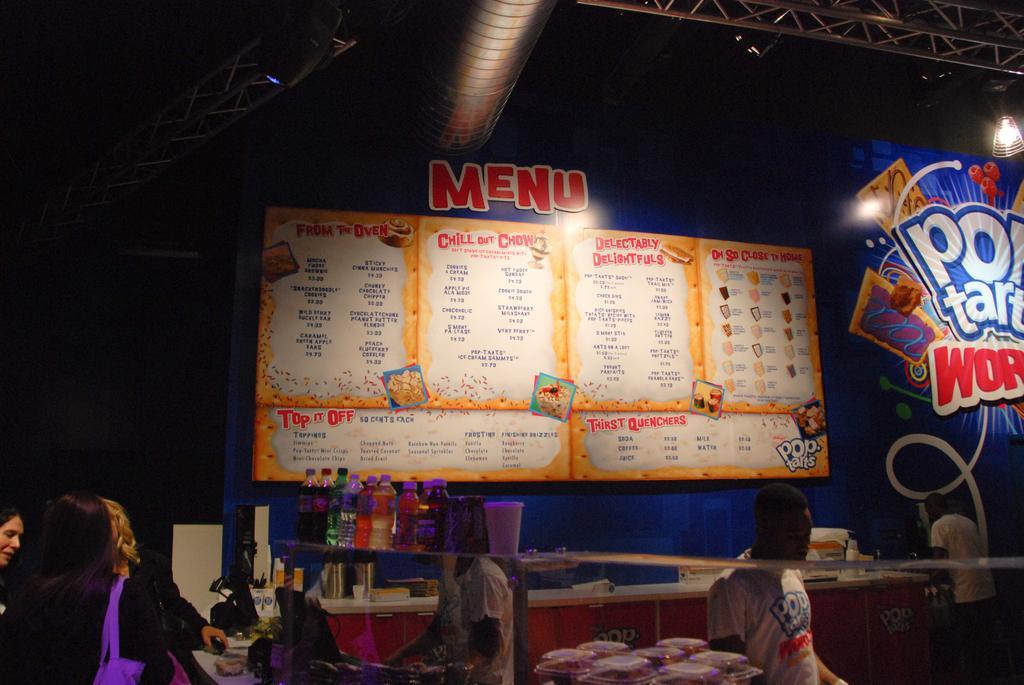In one or two sentences, can you explain what this image depicts? In this picture I can see group of people standing, there are bottles and some other items, there is a board, there are focus lights and lighting truss. 